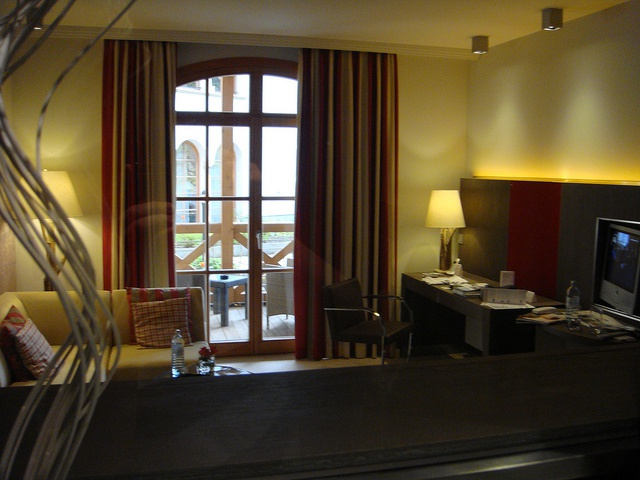Describe the objects in this image and their specific colors. I can see couch in black, maroon, olive, and gray tones, chair in black, darkgreen, and gray tones, tv in black, gray, and navy tones, bottle in black, darkgreen, and gray tones, and bottle in black, gray, and darkgreen tones in this image. 